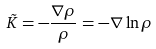<formula> <loc_0><loc_0><loc_500><loc_500>\vec { K } = - \frac { { \nabla } { \rho } } { \rho } = - { \nabla } \ln { \rho }</formula> 